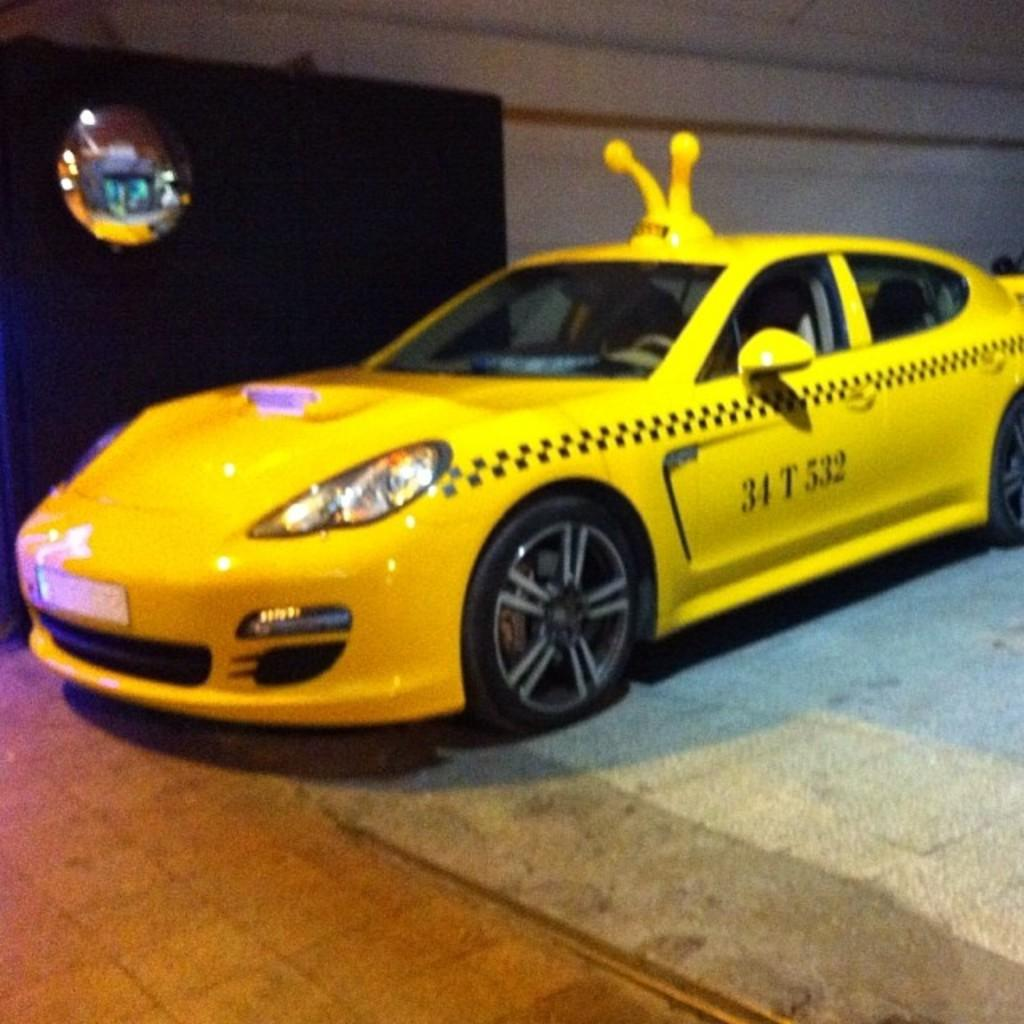<image>
Share a concise interpretation of the image provided. a car that has the number 34 on it 